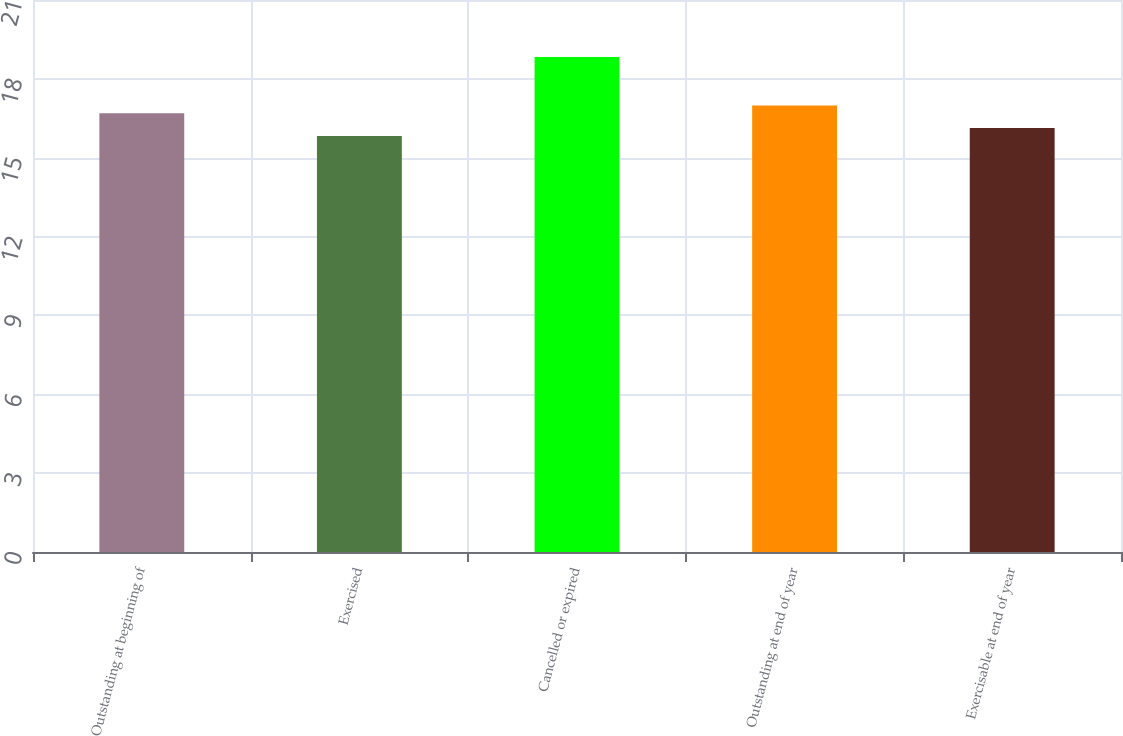<chart> <loc_0><loc_0><loc_500><loc_500><bar_chart><fcel>Outstanding at beginning of<fcel>Exercised<fcel>Cancelled or expired<fcel>Outstanding at end of year<fcel>Exercisable at end of year<nl><fcel>16.69<fcel>15.83<fcel>18.83<fcel>16.99<fcel>16.13<nl></chart> 